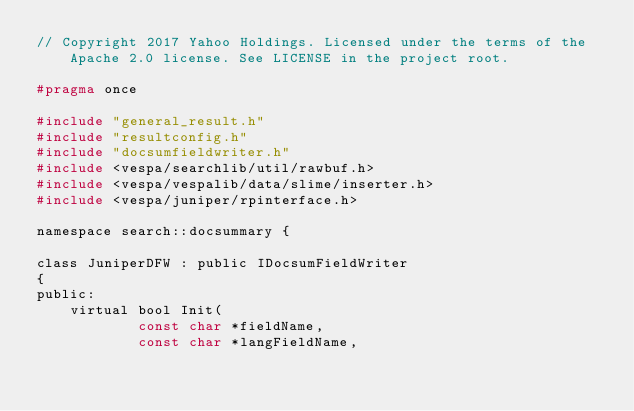Convert code to text. <code><loc_0><loc_0><loc_500><loc_500><_C_>// Copyright 2017 Yahoo Holdings. Licensed under the terms of the Apache 2.0 license. See LICENSE in the project root.

#pragma once

#include "general_result.h"
#include "resultconfig.h"
#include "docsumfieldwriter.h"
#include <vespa/searchlib/util/rawbuf.h>
#include <vespa/vespalib/data/slime/inserter.h>
#include <vespa/juniper/rpinterface.h>

namespace search::docsummary {

class JuniperDFW : public IDocsumFieldWriter
{
public:
    virtual bool Init(
            const char *fieldName,
            const char *langFieldName,</code> 